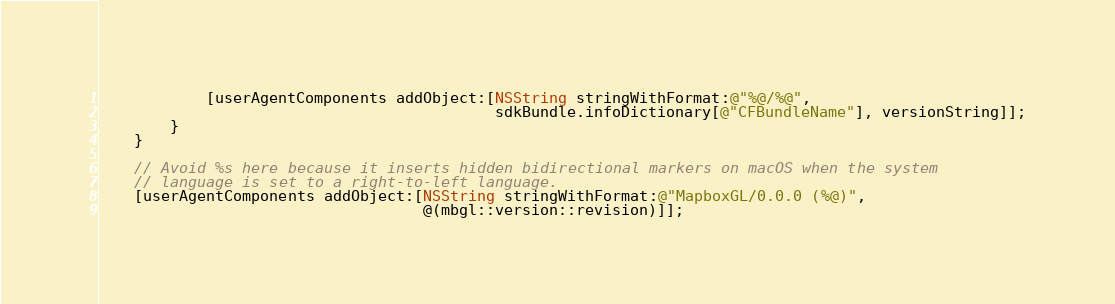<code> <loc_0><loc_0><loc_500><loc_500><_ObjectiveC_>            [userAgentComponents addObject:[NSString stringWithFormat:@"%@/%@",
                                            sdkBundle.infoDictionary[@"CFBundleName"], versionString]];
        }
    }

    // Avoid %s here because it inserts hidden bidirectional markers on macOS when the system
    // language is set to a right-to-left language.
    [userAgentComponents addObject:[NSString stringWithFormat:@"MapboxGL/0.0.0 (%@)",
                                    @(mbgl::version::revision)]];
</code> 